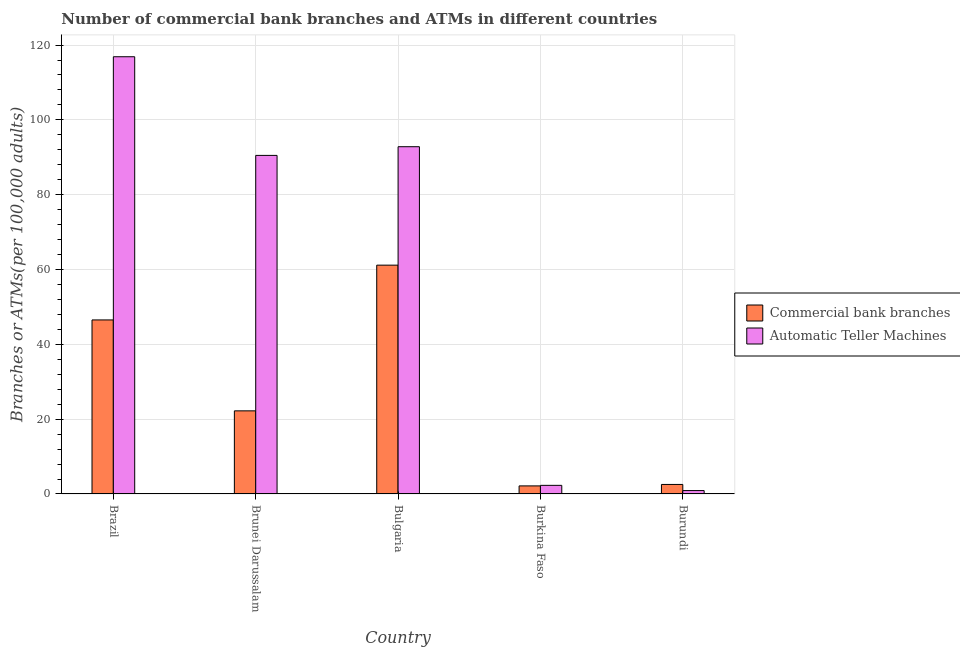How many different coloured bars are there?
Your answer should be compact. 2. How many groups of bars are there?
Keep it short and to the point. 5. Are the number of bars per tick equal to the number of legend labels?
Your answer should be compact. Yes. How many bars are there on the 2nd tick from the left?
Keep it short and to the point. 2. How many bars are there on the 2nd tick from the right?
Your answer should be compact. 2. In how many cases, is the number of bars for a given country not equal to the number of legend labels?
Keep it short and to the point. 0. What is the number of commercal bank branches in Burundi?
Your answer should be compact. 2.55. Across all countries, what is the maximum number of atms?
Your answer should be compact. 116.88. Across all countries, what is the minimum number of atms?
Your response must be concise. 0.91. In which country was the number of commercal bank branches minimum?
Provide a succinct answer. Burkina Faso. What is the total number of atms in the graph?
Provide a succinct answer. 303.42. What is the difference between the number of commercal bank branches in Brazil and that in Bulgaria?
Make the answer very short. -14.64. What is the difference between the number of atms in Brunei Darussalam and the number of commercal bank branches in Burundi?
Make the answer very short. 87.96. What is the average number of commercal bank branches per country?
Offer a very short reply. 26.92. What is the difference between the number of commercal bank branches and number of atms in Brunei Darussalam?
Provide a short and direct response. -68.29. In how many countries, is the number of atms greater than 76 ?
Give a very brief answer. 3. What is the ratio of the number of atms in Burkina Faso to that in Burundi?
Make the answer very short. 2.53. Is the difference between the number of commercal bank branches in Brunei Darussalam and Burkina Faso greater than the difference between the number of atms in Brunei Darussalam and Burkina Faso?
Provide a short and direct response. No. What is the difference between the highest and the second highest number of commercal bank branches?
Your answer should be compact. 14.64. What is the difference between the highest and the lowest number of commercal bank branches?
Provide a succinct answer. 59.01. What does the 1st bar from the left in Burkina Faso represents?
Give a very brief answer. Commercial bank branches. What does the 2nd bar from the right in Burkina Faso represents?
Provide a succinct answer. Commercial bank branches. How many countries are there in the graph?
Your response must be concise. 5. What is the difference between two consecutive major ticks on the Y-axis?
Your answer should be very brief. 20. How are the legend labels stacked?
Provide a short and direct response. Vertical. What is the title of the graph?
Make the answer very short. Number of commercial bank branches and ATMs in different countries. What is the label or title of the X-axis?
Give a very brief answer. Country. What is the label or title of the Y-axis?
Ensure brevity in your answer.  Branches or ATMs(per 100,0 adults). What is the Branches or ATMs(per 100,000 adults) of Commercial bank branches in Brazil?
Your answer should be compact. 46.52. What is the Branches or ATMs(per 100,000 adults) in Automatic Teller Machines in Brazil?
Give a very brief answer. 116.88. What is the Branches or ATMs(per 100,000 adults) of Commercial bank branches in Brunei Darussalam?
Your answer should be compact. 22.22. What is the Branches or ATMs(per 100,000 adults) of Automatic Teller Machines in Brunei Darussalam?
Ensure brevity in your answer.  90.5. What is the Branches or ATMs(per 100,000 adults) of Commercial bank branches in Bulgaria?
Give a very brief answer. 61.16. What is the Branches or ATMs(per 100,000 adults) in Automatic Teller Machines in Bulgaria?
Ensure brevity in your answer.  92.82. What is the Branches or ATMs(per 100,000 adults) of Commercial bank branches in Burkina Faso?
Provide a succinct answer. 2.16. What is the Branches or ATMs(per 100,000 adults) in Automatic Teller Machines in Burkina Faso?
Offer a terse response. 2.3. What is the Branches or ATMs(per 100,000 adults) of Commercial bank branches in Burundi?
Make the answer very short. 2.55. What is the Branches or ATMs(per 100,000 adults) of Automatic Teller Machines in Burundi?
Your answer should be very brief. 0.91. Across all countries, what is the maximum Branches or ATMs(per 100,000 adults) of Commercial bank branches?
Offer a very short reply. 61.16. Across all countries, what is the maximum Branches or ATMs(per 100,000 adults) in Automatic Teller Machines?
Provide a short and direct response. 116.88. Across all countries, what is the minimum Branches or ATMs(per 100,000 adults) in Commercial bank branches?
Provide a succinct answer. 2.16. Across all countries, what is the minimum Branches or ATMs(per 100,000 adults) of Automatic Teller Machines?
Provide a succinct answer. 0.91. What is the total Branches or ATMs(per 100,000 adults) in Commercial bank branches in the graph?
Your answer should be very brief. 134.61. What is the total Branches or ATMs(per 100,000 adults) in Automatic Teller Machines in the graph?
Offer a terse response. 303.42. What is the difference between the Branches or ATMs(per 100,000 adults) in Commercial bank branches in Brazil and that in Brunei Darussalam?
Offer a very short reply. 24.31. What is the difference between the Branches or ATMs(per 100,000 adults) of Automatic Teller Machines in Brazil and that in Brunei Darussalam?
Give a very brief answer. 26.37. What is the difference between the Branches or ATMs(per 100,000 adults) of Commercial bank branches in Brazil and that in Bulgaria?
Offer a terse response. -14.64. What is the difference between the Branches or ATMs(per 100,000 adults) of Automatic Teller Machines in Brazil and that in Bulgaria?
Make the answer very short. 24.05. What is the difference between the Branches or ATMs(per 100,000 adults) of Commercial bank branches in Brazil and that in Burkina Faso?
Ensure brevity in your answer.  44.37. What is the difference between the Branches or ATMs(per 100,000 adults) of Automatic Teller Machines in Brazil and that in Burkina Faso?
Your answer should be compact. 114.57. What is the difference between the Branches or ATMs(per 100,000 adults) of Commercial bank branches in Brazil and that in Burundi?
Ensure brevity in your answer.  43.98. What is the difference between the Branches or ATMs(per 100,000 adults) in Automatic Teller Machines in Brazil and that in Burundi?
Your response must be concise. 115.97. What is the difference between the Branches or ATMs(per 100,000 adults) in Commercial bank branches in Brunei Darussalam and that in Bulgaria?
Make the answer very short. -38.95. What is the difference between the Branches or ATMs(per 100,000 adults) in Automatic Teller Machines in Brunei Darussalam and that in Bulgaria?
Offer a terse response. -2.32. What is the difference between the Branches or ATMs(per 100,000 adults) in Commercial bank branches in Brunei Darussalam and that in Burkina Faso?
Your answer should be very brief. 20.06. What is the difference between the Branches or ATMs(per 100,000 adults) in Automatic Teller Machines in Brunei Darussalam and that in Burkina Faso?
Your response must be concise. 88.2. What is the difference between the Branches or ATMs(per 100,000 adults) of Commercial bank branches in Brunei Darussalam and that in Burundi?
Keep it short and to the point. 19.67. What is the difference between the Branches or ATMs(per 100,000 adults) in Automatic Teller Machines in Brunei Darussalam and that in Burundi?
Keep it short and to the point. 89.59. What is the difference between the Branches or ATMs(per 100,000 adults) in Commercial bank branches in Bulgaria and that in Burkina Faso?
Ensure brevity in your answer.  59.01. What is the difference between the Branches or ATMs(per 100,000 adults) of Automatic Teller Machines in Bulgaria and that in Burkina Faso?
Your answer should be very brief. 90.52. What is the difference between the Branches or ATMs(per 100,000 adults) in Commercial bank branches in Bulgaria and that in Burundi?
Your answer should be compact. 58.62. What is the difference between the Branches or ATMs(per 100,000 adults) of Automatic Teller Machines in Bulgaria and that in Burundi?
Provide a short and direct response. 91.91. What is the difference between the Branches or ATMs(per 100,000 adults) in Commercial bank branches in Burkina Faso and that in Burundi?
Keep it short and to the point. -0.39. What is the difference between the Branches or ATMs(per 100,000 adults) in Automatic Teller Machines in Burkina Faso and that in Burundi?
Ensure brevity in your answer.  1.39. What is the difference between the Branches or ATMs(per 100,000 adults) of Commercial bank branches in Brazil and the Branches or ATMs(per 100,000 adults) of Automatic Teller Machines in Brunei Darussalam?
Offer a very short reply. -43.98. What is the difference between the Branches or ATMs(per 100,000 adults) in Commercial bank branches in Brazil and the Branches or ATMs(per 100,000 adults) in Automatic Teller Machines in Bulgaria?
Your response must be concise. -46.3. What is the difference between the Branches or ATMs(per 100,000 adults) in Commercial bank branches in Brazil and the Branches or ATMs(per 100,000 adults) in Automatic Teller Machines in Burkina Faso?
Offer a very short reply. 44.22. What is the difference between the Branches or ATMs(per 100,000 adults) of Commercial bank branches in Brazil and the Branches or ATMs(per 100,000 adults) of Automatic Teller Machines in Burundi?
Make the answer very short. 45.61. What is the difference between the Branches or ATMs(per 100,000 adults) in Commercial bank branches in Brunei Darussalam and the Branches or ATMs(per 100,000 adults) in Automatic Teller Machines in Bulgaria?
Give a very brief answer. -70.61. What is the difference between the Branches or ATMs(per 100,000 adults) in Commercial bank branches in Brunei Darussalam and the Branches or ATMs(per 100,000 adults) in Automatic Teller Machines in Burkina Faso?
Provide a succinct answer. 19.91. What is the difference between the Branches or ATMs(per 100,000 adults) of Commercial bank branches in Brunei Darussalam and the Branches or ATMs(per 100,000 adults) of Automatic Teller Machines in Burundi?
Ensure brevity in your answer.  21.31. What is the difference between the Branches or ATMs(per 100,000 adults) in Commercial bank branches in Bulgaria and the Branches or ATMs(per 100,000 adults) in Automatic Teller Machines in Burkina Faso?
Give a very brief answer. 58.86. What is the difference between the Branches or ATMs(per 100,000 adults) of Commercial bank branches in Bulgaria and the Branches or ATMs(per 100,000 adults) of Automatic Teller Machines in Burundi?
Your answer should be very brief. 60.26. What is the difference between the Branches or ATMs(per 100,000 adults) in Commercial bank branches in Burkina Faso and the Branches or ATMs(per 100,000 adults) in Automatic Teller Machines in Burundi?
Your response must be concise. 1.25. What is the average Branches or ATMs(per 100,000 adults) in Commercial bank branches per country?
Make the answer very short. 26.92. What is the average Branches or ATMs(per 100,000 adults) of Automatic Teller Machines per country?
Provide a short and direct response. 60.68. What is the difference between the Branches or ATMs(per 100,000 adults) of Commercial bank branches and Branches or ATMs(per 100,000 adults) of Automatic Teller Machines in Brazil?
Your answer should be compact. -70.35. What is the difference between the Branches or ATMs(per 100,000 adults) of Commercial bank branches and Branches or ATMs(per 100,000 adults) of Automatic Teller Machines in Brunei Darussalam?
Make the answer very short. -68.29. What is the difference between the Branches or ATMs(per 100,000 adults) in Commercial bank branches and Branches or ATMs(per 100,000 adults) in Automatic Teller Machines in Bulgaria?
Provide a succinct answer. -31.66. What is the difference between the Branches or ATMs(per 100,000 adults) of Commercial bank branches and Branches or ATMs(per 100,000 adults) of Automatic Teller Machines in Burkina Faso?
Provide a short and direct response. -0.15. What is the difference between the Branches or ATMs(per 100,000 adults) in Commercial bank branches and Branches or ATMs(per 100,000 adults) in Automatic Teller Machines in Burundi?
Ensure brevity in your answer.  1.64. What is the ratio of the Branches or ATMs(per 100,000 adults) of Commercial bank branches in Brazil to that in Brunei Darussalam?
Ensure brevity in your answer.  2.09. What is the ratio of the Branches or ATMs(per 100,000 adults) in Automatic Teller Machines in Brazil to that in Brunei Darussalam?
Offer a terse response. 1.29. What is the ratio of the Branches or ATMs(per 100,000 adults) in Commercial bank branches in Brazil to that in Bulgaria?
Make the answer very short. 0.76. What is the ratio of the Branches or ATMs(per 100,000 adults) in Automatic Teller Machines in Brazil to that in Bulgaria?
Offer a terse response. 1.26. What is the ratio of the Branches or ATMs(per 100,000 adults) in Commercial bank branches in Brazil to that in Burkina Faso?
Offer a very short reply. 21.56. What is the ratio of the Branches or ATMs(per 100,000 adults) of Automatic Teller Machines in Brazil to that in Burkina Faso?
Give a very brief answer. 50.74. What is the ratio of the Branches or ATMs(per 100,000 adults) in Commercial bank branches in Brazil to that in Burundi?
Keep it short and to the point. 18.27. What is the ratio of the Branches or ATMs(per 100,000 adults) of Automatic Teller Machines in Brazil to that in Burundi?
Provide a short and direct response. 128.48. What is the ratio of the Branches or ATMs(per 100,000 adults) of Commercial bank branches in Brunei Darussalam to that in Bulgaria?
Keep it short and to the point. 0.36. What is the ratio of the Branches or ATMs(per 100,000 adults) of Commercial bank branches in Brunei Darussalam to that in Burkina Faso?
Your answer should be compact. 10.3. What is the ratio of the Branches or ATMs(per 100,000 adults) in Automatic Teller Machines in Brunei Darussalam to that in Burkina Faso?
Offer a very short reply. 39.29. What is the ratio of the Branches or ATMs(per 100,000 adults) in Commercial bank branches in Brunei Darussalam to that in Burundi?
Provide a succinct answer. 8.72. What is the ratio of the Branches or ATMs(per 100,000 adults) of Automatic Teller Machines in Brunei Darussalam to that in Burundi?
Provide a succinct answer. 99.49. What is the ratio of the Branches or ATMs(per 100,000 adults) in Commercial bank branches in Bulgaria to that in Burkina Faso?
Offer a terse response. 28.34. What is the ratio of the Branches or ATMs(per 100,000 adults) in Automatic Teller Machines in Bulgaria to that in Burkina Faso?
Your response must be concise. 40.3. What is the ratio of the Branches or ATMs(per 100,000 adults) of Commercial bank branches in Bulgaria to that in Burundi?
Provide a succinct answer. 24.01. What is the ratio of the Branches or ATMs(per 100,000 adults) of Automatic Teller Machines in Bulgaria to that in Burundi?
Offer a terse response. 102.04. What is the ratio of the Branches or ATMs(per 100,000 adults) of Commercial bank branches in Burkina Faso to that in Burundi?
Make the answer very short. 0.85. What is the ratio of the Branches or ATMs(per 100,000 adults) in Automatic Teller Machines in Burkina Faso to that in Burundi?
Your response must be concise. 2.53. What is the difference between the highest and the second highest Branches or ATMs(per 100,000 adults) in Commercial bank branches?
Provide a short and direct response. 14.64. What is the difference between the highest and the second highest Branches or ATMs(per 100,000 adults) in Automatic Teller Machines?
Provide a short and direct response. 24.05. What is the difference between the highest and the lowest Branches or ATMs(per 100,000 adults) of Commercial bank branches?
Make the answer very short. 59.01. What is the difference between the highest and the lowest Branches or ATMs(per 100,000 adults) of Automatic Teller Machines?
Provide a short and direct response. 115.97. 